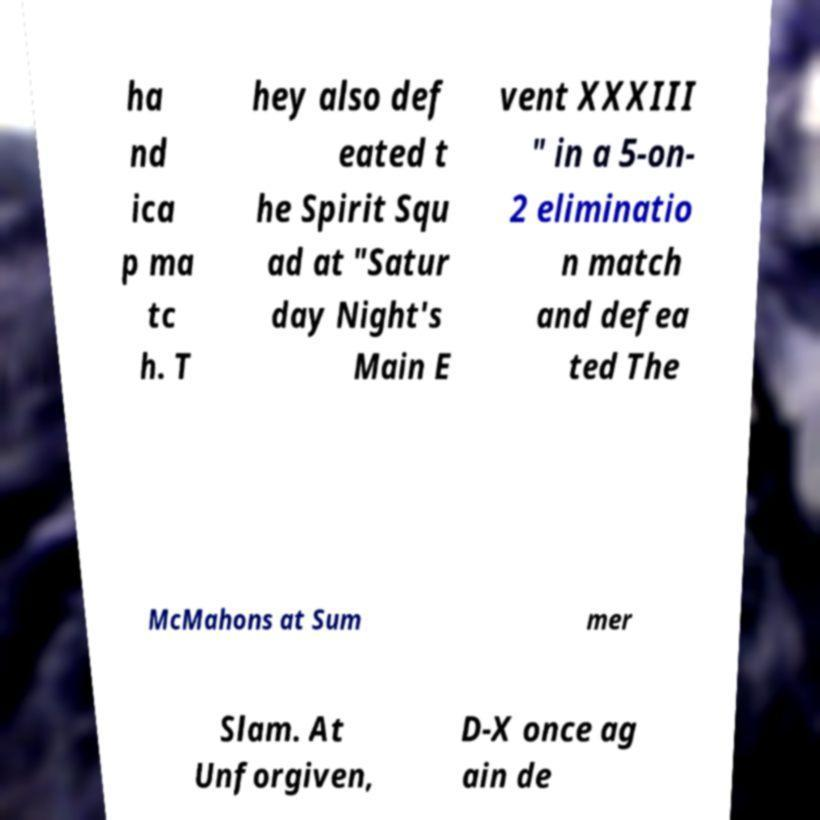Can you read and provide the text displayed in the image?This photo seems to have some interesting text. Can you extract and type it out for me? ha nd ica p ma tc h. T hey also def eated t he Spirit Squ ad at "Satur day Night's Main E vent XXXIII " in a 5-on- 2 eliminatio n match and defea ted The McMahons at Sum mer Slam. At Unforgiven, D-X once ag ain de 